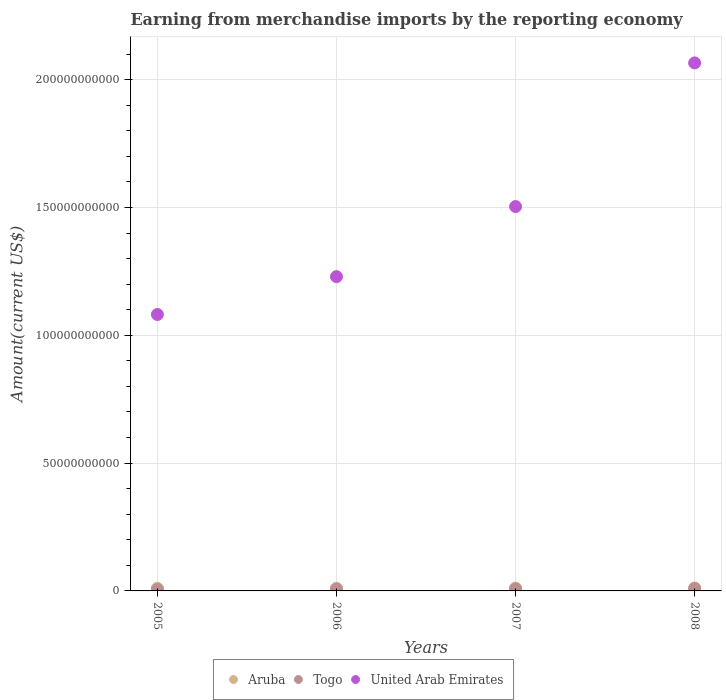How many different coloured dotlines are there?
Provide a succinct answer. 3. Is the number of dotlines equal to the number of legend labels?
Your answer should be very brief. Yes. What is the amount earned from merchandise imports in Togo in 2007?
Offer a very short reply. 7.87e+08. Across all years, what is the maximum amount earned from merchandise imports in United Arab Emirates?
Give a very brief answer. 2.07e+11. Across all years, what is the minimum amount earned from merchandise imports in Aruba?
Provide a succinct answer. 1.03e+09. In which year was the amount earned from merchandise imports in United Arab Emirates maximum?
Your answer should be very brief. 2008. In which year was the amount earned from merchandise imports in Togo minimum?
Your response must be concise. 2005. What is the total amount earned from merchandise imports in Aruba in the graph?
Offer a terse response. 4.32e+09. What is the difference between the amount earned from merchandise imports in United Arab Emirates in 2007 and that in 2008?
Ensure brevity in your answer.  -5.62e+1. What is the difference between the amount earned from merchandise imports in Aruba in 2006 and the amount earned from merchandise imports in United Arab Emirates in 2008?
Give a very brief answer. -2.05e+11. What is the average amount earned from merchandise imports in Togo per year?
Your answer should be very brief. 7.68e+08. In the year 2008, what is the difference between the amount earned from merchandise imports in United Arab Emirates and amount earned from merchandise imports in Aruba?
Keep it short and to the point. 2.05e+11. What is the ratio of the amount earned from merchandise imports in United Arab Emirates in 2006 to that in 2008?
Offer a terse response. 0.6. Is the amount earned from merchandise imports in Togo in 2006 less than that in 2007?
Ensure brevity in your answer.  Yes. Is the difference between the amount earned from merchandise imports in United Arab Emirates in 2007 and 2008 greater than the difference between the amount earned from merchandise imports in Aruba in 2007 and 2008?
Provide a short and direct response. No. What is the difference between the highest and the second highest amount earned from merchandise imports in Togo?
Provide a succinct answer. 1.71e+08. What is the difference between the highest and the lowest amount earned from merchandise imports in United Arab Emirates?
Provide a short and direct response. 9.84e+1. Is the sum of the amount earned from merchandise imports in Togo in 2006 and 2007 greater than the maximum amount earned from merchandise imports in Aruba across all years?
Provide a succinct answer. Yes. Is it the case that in every year, the sum of the amount earned from merchandise imports in United Arab Emirates and amount earned from merchandise imports in Aruba  is greater than the amount earned from merchandise imports in Togo?
Offer a terse response. Yes. Does the amount earned from merchandise imports in United Arab Emirates monotonically increase over the years?
Offer a terse response. Yes. Is the amount earned from merchandise imports in United Arab Emirates strictly greater than the amount earned from merchandise imports in Togo over the years?
Make the answer very short. Yes. What is the difference between two consecutive major ticks on the Y-axis?
Your response must be concise. 5.00e+1. Does the graph contain grids?
Provide a succinct answer. Yes. How many legend labels are there?
Provide a short and direct response. 3. What is the title of the graph?
Your answer should be compact. Earning from merchandise imports by the reporting economy. Does "Maldives" appear as one of the legend labels in the graph?
Make the answer very short. No. What is the label or title of the X-axis?
Provide a short and direct response. Years. What is the label or title of the Y-axis?
Your answer should be very brief. Amount(current US$). What is the Amount(current US$) in Aruba in 2005?
Offer a terse response. 1.03e+09. What is the Amount(current US$) of Togo in 2005?
Give a very brief answer. 5.96e+08. What is the Amount(current US$) of United Arab Emirates in 2005?
Ensure brevity in your answer.  1.08e+11. What is the Amount(current US$) of Aruba in 2006?
Provide a succinct answer. 1.04e+09. What is the Amount(current US$) of Togo in 2006?
Make the answer very short. 7.29e+08. What is the Amount(current US$) in United Arab Emirates in 2006?
Offer a very short reply. 1.23e+11. What is the Amount(current US$) in Aruba in 2007?
Offer a terse response. 1.11e+09. What is the Amount(current US$) in Togo in 2007?
Provide a short and direct response. 7.87e+08. What is the Amount(current US$) in United Arab Emirates in 2007?
Provide a succinct answer. 1.50e+11. What is the Amount(current US$) in Aruba in 2008?
Provide a succinct answer. 1.13e+09. What is the Amount(current US$) of Togo in 2008?
Give a very brief answer. 9.58e+08. What is the Amount(current US$) in United Arab Emirates in 2008?
Your response must be concise. 2.07e+11. Across all years, what is the maximum Amount(current US$) in Aruba?
Offer a very short reply. 1.13e+09. Across all years, what is the maximum Amount(current US$) of Togo?
Make the answer very short. 9.58e+08. Across all years, what is the maximum Amount(current US$) of United Arab Emirates?
Provide a short and direct response. 2.07e+11. Across all years, what is the minimum Amount(current US$) of Aruba?
Make the answer very short. 1.03e+09. Across all years, what is the minimum Amount(current US$) in Togo?
Give a very brief answer. 5.96e+08. Across all years, what is the minimum Amount(current US$) in United Arab Emirates?
Your answer should be very brief. 1.08e+11. What is the total Amount(current US$) of Aruba in the graph?
Your response must be concise. 4.32e+09. What is the total Amount(current US$) of Togo in the graph?
Keep it short and to the point. 3.07e+09. What is the total Amount(current US$) in United Arab Emirates in the graph?
Keep it short and to the point. 5.88e+11. What is the difference between the Amount(current US$) of Aruba in 2005 and that in 2006?
Provide a succinct answer. -1.13e+07. What is the difference between the Amount(current US$) of Togo in 2005 and that in 2006?
Make the answer very short. -1.34e+08. What is the difference between the Amount(current US$) in United Arab Emirates in 2005 and that in 2006?
Offer a terse response. -1.48e+1. What is the difference between the Amount(current US$) of Aruba in 2005 and that in 2007?
Provide a short and direct response. -8.38e+07. What is the difference between the Amount(current US$) of Togo in 2005 and that in 2007?
Provide a succinct answer. -1.91e+08. What is the difference between the Amount(current US$) of United Arab Emirates in 2005 and that in 2007?
Offer a terse response. -4.22e+1. What is the difference between the Amount(current US$) of Aruba in 2005 and that in 2008?
Provide a succinct answer. -1.04e+08. What is the difference between the Amount(current US$) in Togo in 2005 and that in 2008?
Give a very brief answer. -3.62e+08. What is the difference between the Amount(current US$) in United Arab Emirates in 2005 and that in 2008?
Provide a succinct answer. -9.84e+1. What is the difference between the Amount(current US$) of Aruba in 2006 and that in 2007?
Make the answer very short. -7.25e+07. What is the difference between the Amount(current US$) of Togo in 2006 and that in 2007?
Provide a succinct answer. -5.77e+07. What is the difference between the Amount(current US$) of United Arab Emirates in 2006 and that in 2007?
Give a very brief answer. -2.74e+1. What is the difference between the Amount(current US$) in Aruba in 2006 and that in 2008?
Offer a terse response. -9.31e+07. What is the difference between the Amount(current US$) of Togo in 2006 and that in 2008?
Make the answer very short. -2.28e+08. What is the difference between the Amount(current US$) of United Arab Emirates in 2006 and that in 2008?
Ensure brevity in your answer.  -8.36e+1. What is the difference between the Amount(current US$) in Aruba in 2007 and that in 2008?
Make the answer very short. -2.06e+07. What is the difference between the Amount(current US$) in Togo in 2007 and that in 2008?
Provide a succinct answer. -1.71e+08. What is the difference between the Amount(current US$) of United Arab Emirates in 2007 and that in 2008?
Offer a terse response. -5.62e+1. What is the difference between the Amount(current US$) in Aruba in 2005 and the Amount(current US$) in Togo in 2006?
Provide a succinct answer. 3.01e+08. What is the difference between the Amount(current US$) in Aruba in 2005 and the Amount(current US$) in United Arab Emirates in 2006?
Your response must be concise. -1.22e+11. What is the difference between the Amount(current US$) of Togo in 2005 and the Amount(current US$) of United Arab Emirates in 2006?
Provide a short and direct response. -1.22e+11. What is the difference between the Amount(current US$) of Aruba in 2005 and the Amount(current US$) of Togo in 2007?
Your response must be concise. 2.43e+08. What is the difference between the Amount(current US$) of Aruba in 2005 and the Amount(current US$) of United Arab Emirates in 2007?
Make the answer very short. -1.49e+11. What is the difference between the Amount(current US$) of Togo in 2005 and the Amount(current US$) of United Arab Emirates in 2007?
Give a very brief answer. -1.50e+11. What is the difference between the Amount(current US$) of Aruba in 2005 and the Amount(current US$) of Togo in 2008?
Ensure brevity in your answer.  7.24e+07. What is the difference between the Amount(current US$) in Aruba in 2005 and the Amount(current US$) in United Arab Emirates in 2008?
Offer a very short reply. -2.06e+11. What is the difference between the Amount(current US$) of Togo in 2005 and the Amount(current US$) of United Arab Emirates in 2008?
Provide a short and direct response. -2.06e+11. What is the difference between the Amount(current US$) of Aruba in 2006 and the Amount(current US$) of Togo in 2007?
Make the answer very short. 2.54e+08. What is the difference between the Amount(current US$) in Aruba in 2006 and the Amount(current US$) in United Arab Emirates in 2007?
Make the answer very short. -1.49e+11. What is the difference between the Amount(current US$) in Togo in 2006 and the Amount(current US$) in United Arab Emirates in 2007?
Keep it short and to the point. -1.50e+11. What is the difference between the Amount(current US$) of Aruba in 2006 and the Amount(current US$) of Togo in 2008?
Ensure brevity in your answer.  8.36e+07. What is the difference between the Amount(current US$) in Aruba in 2006 and the Amount(current US$) in United Arab Emirates in 2008?
Your answer should be very brief. -2.05e+11. What is the difference between the Amount(current US$) in Togo in 2006 and the Amount(current US$) in United Arab Emirates in 2008?
Give a very brief answer. -2.06e+11. What is the difference between the Amount(current US$) in Aruba in 2007 and the Amount(current US$) in Togo in 2008?
Give a very brief answer. 1.56e+08. What is the difference between the Amount(current US$) of Aruba in 2007 and the Amount(current US$) of United Arab Emirates in 2008?
Your response must be concise. -2.05e+11. What is the difference between the Amount(current US$) of Togo in 2007 and the Amount(current US$) of United Arab Emirates in 2008?
Your answer should be very brief. -2.06e+11. What is the average Amount(current US$) in Aruba per year?
Your answer should be compact. 1.08e+09. What is the average Amount(current US$) in Togo per year?
Your response must be concise. 7.68e+08. What is the average Amount(current US$) in United Arab Emirates per year?
Keep it short and to the point. 1.47e+11. In the year 2005, what is the difference between the Amount(current US$) of Aruba and Amount(current US$) of Togo?
Give a very brief answer. 4.34e+08. In the year 2005, what is the difference between the Amount(current US$) of Aruba and Amount(current US$) of United Arab Emirates?
Keep it short and to the point. -1.07e+11. In the year 2005, what is the difference between the Amount(current US$) of Togo and Amount(current US$) of United Arab Emirates?
Your response must be concise. -1.08e+11. In the year 2006, what is the difference between the Amount(current US$) in Aruba and Amount(current US$) in Togo?
Give a very brief answer. 3.12e+08. In the year 2006, what is the difference between the Amount(current US$) of Aruba and Amount(current US$) of United Arab Emirates?
Provide a succinct answer. -1.22e+11. In the year 2006, what is the difference between the Amount(current US$) in Togo and Amount(current US$) in United Arab Emirates?
Make the answer very short. -1.22e+11. In the year 2007, what is the difference between the Amount(current US$) of Aruba and Amount(current US$) of Togo?
Give a very brief answer. 3.27e+08. In the year 2007, what is the difference between the Amount(current US$) of Aruba and Amount(current US$) of United Arab Emirates?
Provide a succinct answer. -1.49e+11. In the year 2007, what is the difference between the Amount(current US$) of Togo and Amount(current US$) of United Arab Emirates?
Make the answer very short. -1.50e+11. In the year 2008, what is the difference between the Amount(current US$) in Aruba and Amount(current US$) in Togo?
Offer a very short reply. 1.77e+08. In the year 2008, what is the difference between the Amount(current US$) of Aruba and Amount(current US$) of United Arab Emirates?
Offer a very short reply. -2.05e+11. In the year 2008, what is the difference between the Amount(current US$) of Togo and Amount(current US$) of United Arab Emirates?
Provide a succinct answer. -2.06e+11. What is the ratio of the Amount(current US$) of Aruba in 2005 to that in 2006?
Give a very brief answer. 0.99. What is the ratio of the Amount(current US$) in Togo in 2005 to that in 2006?
Your answer should be very brief. 0.82. What is the ratio of the Amount(current US$) in United Arab Emirates in 2005 to that in 2006?
Ensure brevity in your answer.  0.88. What is the ratio of the Amount(current US$) of Aruba in 2005 to that in 2007?
Your answer should be compact. 0.92. What is the ratio of the Amount(current US$) of Togo in 2005 to that in 2007?
Make the answer very short. 0.76. What is the ratio of the Amount(current US$) in United Arab Emirates in 2005 to that in 2007?
Provide a succinct answer. 0.72. What is the ratio of the Amount(current US$) of Aruba in 2005 to that in 2008?
Keep it short and to the point. 0.91. What is the ratio of the Amount(current US$) in Togo in 2005 to that in 2008?
Provide a succinct answer. 0.62. What is the ratio of the Amount(current US$) of United Arab Emirates in 2005 to that in 2008?
Provide a short and direct response. 0.52. What is the ratio of the Amount(current US$) of Aruba in 2006 to that in 2007?
Offer a terse response. 0.93. What is the ratio of the Amount(current US$) of Togo in 2006 to that in 2007?
Provide a succinct answer. 0.93. What is the ratio of the Amount(current US$) in United Arab Emirates in 2006 to that in 2007?
Provide a succinct answer. 0.82. What is the ratio of the Amount(current US$) in Aruba in 2006 to that in 2008?
Offer a terse response. 0.92. What is the ratio of the Amount(current US$) of Togo in 2006 to that in 2008?
Your answer should be very brief. 0.76. What is the ratio of the Amount(current US$) of United Arab Emirates in 2006 to that in 2008?
Your answer should be compact. 0.6. What is the ratio of the Amount(current US$) in Aruba in 2007 to that in 2008?
Give a very brief answer. 0.98. What is the ratio of the Amount(current US$) in Togo in 2007 to that in 2008?
Keep it short and to the point. 0.82. What is the ratio of the Amount(current US$) in United Arab Emirates in 2007 to that in 2008?
Offer a terse response. 0.73. What is the difference between the highest and the second highest Amount(current US$) in Aruba?
Make the answer very short. 2.06e+07. What is the difference between the highest and the second highest Amount(current US$) in Togo?
Your answer should be very brief. 1.71e+08. What is the difference between the highest and the second highest Amount(current US$) in United Arab Emirates?
Your answer should be compact. 5.62e+1. What is the difference between the highest and the lowest Amount(current US$) in Aruba?
Make the answer very short. 1.04e+08. What is the difference between the highest and the lowest Amount(current US$) of Togo?
Provide a succinct answer. 3.62e+08. What is the difference between the highest and the lowest Amount(current US$) of United Arab Emirates?
Your answer should be compact. 9.84e+1. 